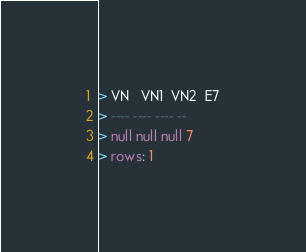<code> <loc_0><loc_0><loc_500><loc_500><_SQL_>> VN   VN1  VN2  E7
> ---- ---- ---- --
> null null null 7
> rows: 1
</code> 